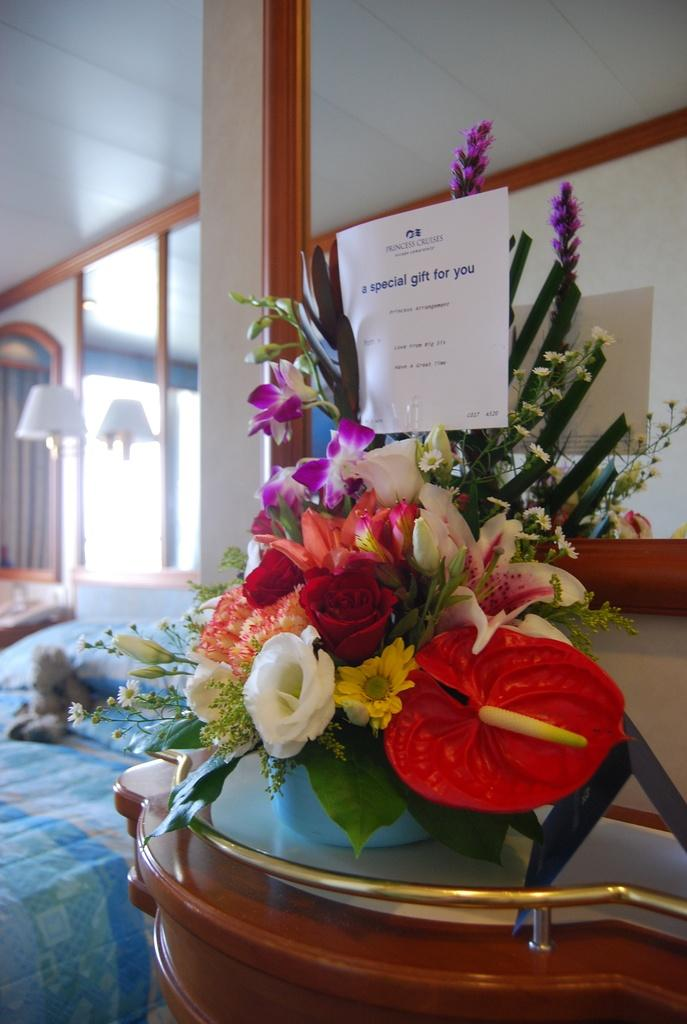What object can be seen in the image? There is a flower vase in the image. Where is the flower vase located? The flower vase is on a desk. What type of animal can be seen swimming in the sea near the land in the image? There is no land, sea, or animal present in the image; it only features a flower vase on a desk. 